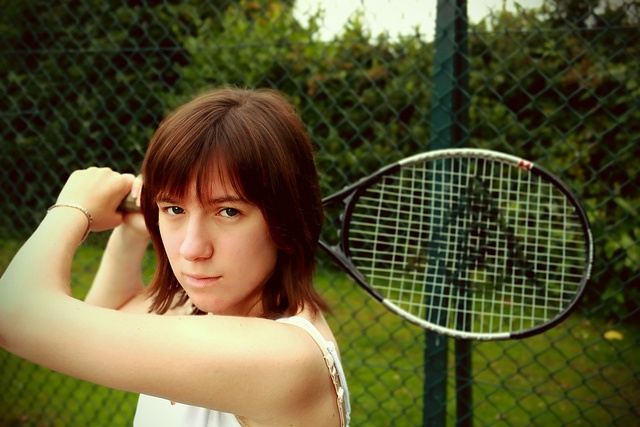Describe the objects in this image and their specific colors. I can see people in black, khaki, tan, and maroon tones and tennis racket in black, darkgreen, and olive tones in this image. 